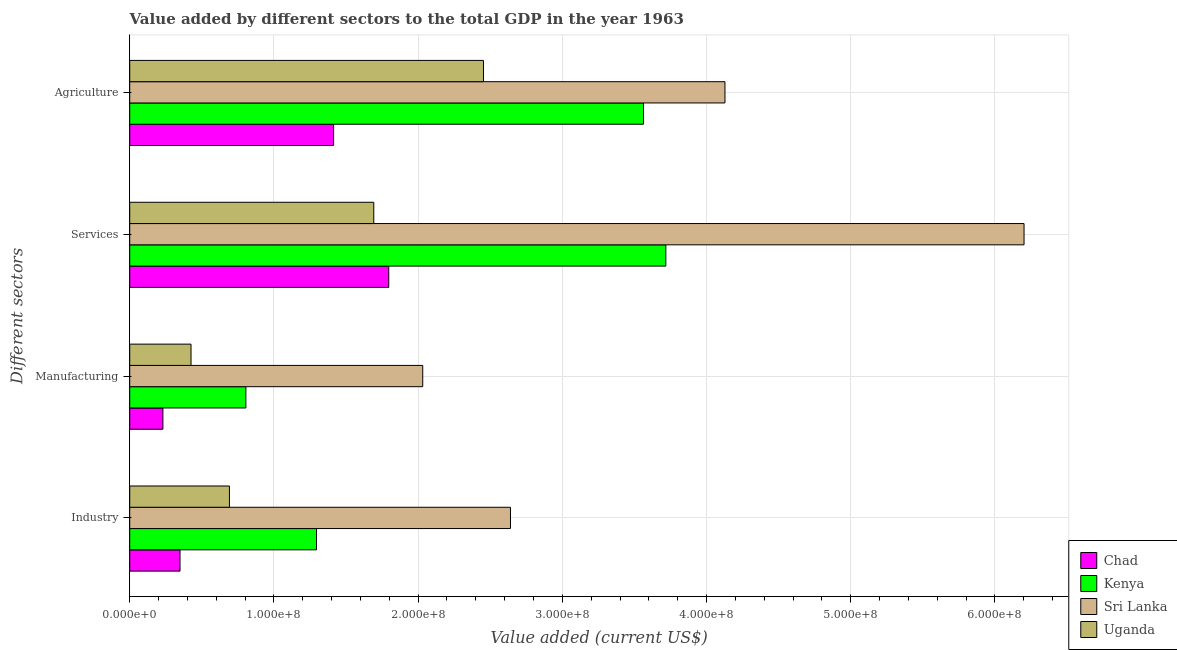How many different coloured bars are there?
Provide a succinct answer. 4. Are the number of bars per tick equal to the number of legend labels?
Ensure brevity in your answer.  Yes. How many bars are there on the 3rd tick from the bottom?
Offer a terse response. 4. What is the label of the 3rd group of bars from the top?
Make the answer very short. Manufacturing. What is the value added by manufacturing sector in Chad?
Your answer should be very brief. 2.30e+07. Across all countries, what is the maximum value added by agricultural sector?
Ensure brevity in your answer.  4.13e+08. Across all countries, what is the minimum value added by agricultural sector?
Ensure brevity in your answer.  1.41e+08. In which country was the value added by services sector maximum?
Offer a very short reply. Sri Lanka. In which country was the value added by services sector minimum?
Offer a terse response. Uganda. What is the total value added by agricultural sector in the graph?
Offer a terse response. 1.16e+09. What is the difference between the value added by industrial sector in Sri Lanka and that in Kenya?
Your answer should be compact. 1.35e+08. What is the difference between the value added by agricultural sector in Uganda and the value added by industrial sector in Sri Lanka?
Provide a short and direct response. -1.87e+07. What is the average value added by manufacturing sector per country?
Your response must be concise. 8.73e+07. What is the difference between the value added by services sector and value added by agricultural sector in Kenya?
Your answer should be compact. 1.55e+07. In how many countries, is the value added by agricultural sector greater than 240000000 US$?
Give a very brief answer. 3. What is the ratio of the value added by industrial sector in Sri Lanka to that in Uganda?
Your answer should be very brief. 3.82. Is the value added by manufacturing sector in Kenya less than that in Sri Lanka?
Provide a succinct answer. Yes. Is the difference between the value added by agricultural sector in Sri Lanka and Kenya greater than the difference between the value added by industrial sector in Sri Lanka and Kenya?
Make the answer very short. No. What is the difference between the highest and the second highest value added by agricultural sector?
Make the answer very short. 5.65e+07. What is the difference between the highest and the lowest value added by agricultural sector?
Your answer should be very brief. 2.71e+08. In how many countries, is the value added by industrial sector greater than the average value added by industrial sector taken over all countries?
Provide a short and direct response. 2. Is the sum of the value added by services sector in Kenya and Sri Lanka greater than the maximum value added by manufacturing sector across all countries?
Give a very brief answer. Yes. What does the 4th bar from the top in Industry represents?
Offer a very short reply. Chad. What does the 1st bar from the bottom in Industry represents?
Provide a short and direct response. Chad. Is it the case that in every country, the sum of the value added by industrial sector and value added by manufacturing sector is greater than the value added by services sector?
Provide a succinct answer. No. How many bars are there?
Your answer should be very brief. 16. Are all the bars in the graph horizontal?
Offer a very short reply. Yes. Are the values on the major ticks of X-axis written in scientific E-notation?
Provide a succinct answer. Yes. Does the graph contain any zero values?
Make the answer very short. No. Does the graph contain grids?
Give a very brief answer. Yes. Where does the legend appear in the graph?
Provide a succinct answer. Bottom right. How many legend labels are there?
Ensure brevity in your answer.  4. What is the title of the graph?
Provide a short and direct response. Value added by different sectors to the total GDP in the year 1963. Does "Timor-Leste" appear as one of the legend labels in the graph?
Offer a very short reply. No. What is the label or title of the X-axis?
Your answer should be very brief. Value added (current US$). What is the label or title of the Y-axis?
Provide a short and direct response. Different sectors. What is the Value added (current US$) in Chad in Industry?
Provide a short and direct response. 3.49e+07. What is the Value added (current US$) in Kenya in Industry?
Make the answer very short. 1.30e+08. What is the Value added (current US$) of Sri Lanka in Industry?
Offer a terse response. 2.64e+08. What is the Value added (current US$) of Uganda in Industry?
Your response must be concise. 6.91e+07. What is the Value added (current US$) in Chad in Manufacturing?
Your response must be concise. 2.30e+07. What is the Value added (current US$) of Kenya in Manufacturing?
Ensure brevity in your answer.  8.05e+07. What is the Value added (current US$) in Sri Lanka in Manufacturing?
Provide a short and direct response. 2.03e+08. What is the Value added (current US$) of Uganda in Manufacturing?
Offer a very short reply. 4.25e+07. What is the Value added (current US$) in Chad in Services?
Provide a short and direct response. 1.80e+08. What is the Value added (current US$) in Kenya in Services?
Keep it short and to the point. 3.72e+08. What is the Value added (current US$) in Sri Lanka in Services?
Provide a succinct answer. 6.20e+08. What is the Value added (current US$) in Uganda in Services?
Provide a short and direct response. 1.69e+08. What is the Value added (current US$) in Chad in Agriculture?
Offer a terse response. 1.41e+08. What is the Value added (current US$) in Kenya in Agriculture?
Ensure brevity in your answer.  3.56e+08. What is the Value added (current US$) of Sri Lanka in Agriculture?
Offer a terse response. 4.13e+08. What is the Value added (current US$) of Uganda in Agriculture?
Offer a terse response. 2.45e+08. Across all Different sectors, what is the maximum Value added (current US$) of Chad?
Your answer should be compact. 1.80e+08. Across all Different sectors, what is the maximum Value added (current US$) in Kenya?
Offer a terse response. 3.72e+08. Across all Different sectors, what is the maximum Value added (current US$) of Sri Lanka?
Offer a very short reply. 6.20e+08. Across all Different sectors, what is the maximum Value added (current US$) in Uganda?
Provide a succinct answer. 2.45e+08. Across all Different sectors, what is the minimum Value added (current US$) of Chad?
Ensure brevity in your answer.  2.30e+07. Across all Different sectors, what is the minimum Value added (current US$) in Kenya?
Provide a succinct answer. 8.05e+07. Across all Different sectors, what is the minimum Value added (current US$) in Sri Lanka?
Your answer should be compact. 2.03e+08. Across all Different sectors, what is the minimum Value added (current US$) in Uganda?
Your response must be concise. 4.25e+07. What is the total Value added (current US$) of Chad in the graph?
Provide a succinct answer. 3.79e+08. What is the total Value added (current US$) in Kenya in the graph?
Provide a succinct answer. 9.38e+08. What is the total Value added (current US$) of Sri Lanka in the graph?
Give a very brief answer. 1.50e+09. What is the total Value added (current US$) in Uganda in the graph?
Your answer should be very brief. 5.26e+08. What is the difference between the Value added (current US$) of Chad in Industry and that in Manufacturing?
Your answer should be very brief. 1.19e+07. What is the difference between the Value added (current US$) of Kenya in Industry and that in Manufacturing?
Give a very brief answer. 4.90e+07. What is the difference between the Value added (current US$) in Sri Lanka in Industry and that in Manufacturing?
Your response must be concise. 6.08e+07. What is the difference between the Value added (current US$) in Uganda in Industry and that in Manufacturing?
Ensure brevity in your answer.  2.66e+07. What is the difference between the Value added (current US$) in Chad in Industry and that in Services?
Make the answer very short. -1.45e+08. What is the difference between the Value added (current US$) in Kenya in Industry and that in Services?
Give a very brief answer. -2.42e+08. What is the difference between the Value added (current US$) of Sri Lanka in Industry and that in Services?
Make the answer very short. -3.56e+08. What is the difference between the Value added (current US$) of Uganda in Industry and that in Services?
Make the answer very short. -1.00e+08. What is the difference between the Value added (current US$) of Chad in Industry and that in Agriculture?
Offer a very short reply. -1.07e+08. What is the difference between the Value added (current US$) of Kenya in Industry and that in Agriculture?
Keep it short and to the point. -2.27e+08. What is the difference between the Value added (current US$) of Sri Lanka in Industry and that in Agriculture?
Your answer should be compact. -1.49e+08. What is the difference between the Value added (current US$) of Uganda in Industry and that in Agriculture?
Ensure brevity in your answer.  -1.76e+08. What is the difference between the Value added (current US$) in Chad in Manufacturing and that in Services?
Provide a short and direct response. -1.57e+08. What is the difference between the Value added (current US$) of Kenya in Manufacturing and that in Services?
Provide a succinct answer. -2.91e+08. What is the difference between the Value added (current US$) of Sri Lanka in Manufacturing and that in Services?
Offer a terse response. -4.17e+08. What is the difference between the Value added (current US$) in Uganda in Manufacturing and that in Services?
Your response must be concise. -1.27e+08. What is the difference between the Value added (current US$) in Chad in Manufacturing and that in Agriculture?
Provide a short and direct response. -1.18e+08. What is the difference between the Value added (current US$) of Kenya in Manufacturing and that in Agriculture?
Make the answer very short. -2.76e+08. What is the difference between the Value added (current US$) in Sri Lanka in Manufacturing and that in Agriculture?
Your response must be concise. -2.10e+08. What is the difference between the Value added (current US$) in Uganda in Manufacturing and that in Agriculture?
Give a very brief answer. -2.03e+08. What is the difference between the Value added (current US$) in Chad in Services and that in Agriculture?
Your answer should be compact. 3.82e+07. What is the difference between the Value added (current US$) in Kenya in Services and that in Agriculture?
Give a very brief answer. 1.55e+07. What is the difference between the Value added (current US$) of Sri Lanka in Services and that in Agriculture?
Make the answer very short. 2.07e+08. What is the difference between the Value added (current US$) in Uganda in Services and that in Agriculture?
Your response must be concise. -7.61e+07. What is the difference between the Value added (current US$) in Chad in Industry and the Value added (current US$) in Kenya in Manufacturing?
Offer a very short reply. -4.57e+07. What is the difference between the Value added (current US$) in Chad in Industry and the Value added (current US$) in Sri Lanka in Manufacturing?
Provide a succinct answer. -1.68e+08. What is the difference between the Value added (current US$) in Chad in Industry and the Value added (current US$) in Uganda in Manufacturing?
Offer a very short reply. -7.63e+06. What is the difference between the Value added (current US$) of Kenya in Industry and the Value added (current US$) of Sri Lanka in Manufacturing?
Provide a short and direct response. -7.37e+07. What is the difference between the Value added (current US$) of Kenya in Industry and the Value added (current US$) of Uganda in Manufacturing?
Offer a terse response. 8.70e+07. What is the difference between the Value added (current US$) in Sri Lanka in Industry and the Value added (current US$) in Uganda in Manufacturing?
Provide a short and direct response. 2.22e+08. What is the difference between the Value added (current US$) of Chad in Industry and the Value added (current US$) of Kenya in Services?
Make the answer very short. -3.37e+08. What is the difference between the Value added (current US$) in Chad in Industry and the Value added (current US$) in Sri Lanka in Services?
Your response must be concise. -5.85e+08. What is the difference between the Value added (current US$) in Chad in Industry and the Value added (current US$) in Uganda in Services?
Keep it short and to the point. -1.34e+08. What is the difference between the Value added (current US$) in Kenya in Industry and the Value added (current US$) in Sri Lanka in Services?
Offer a terse response. -4.91e+08. What is the difference between the Value added (current US$) in Kenya in Industry and the Value added (current US$) in Uganda in Services?
Your answer should be very brief. -3.97e+07. What is the difference between the Value added (current US$) of Sri Lanka in Industry and the Value added (current US$) of Uganda in Services?
Give a very brief answer. 9.48e+07. What is the difference between the Value added (current US$) of Chad in Industry and the Value added (current US$) of Kenya in Agriculture?
Keep it short and to the point. -3.21e+08. What is the difference between the Value added (current US$) in Chad in Industry and the Value added (current US$) in Sri Lanka in Agriculture?
Your answer should be very brief. -3.78e+08. What is the difference between the Value added (current US$) of Chad in Industry and the Value added (current US$) of Uganda in Agriculture?
Keep it short and to the point. -2.10e+08. What is the difference between the Value added (current US$) of Kenya in Industry and the Value added (current US$) of Sri Lanka in Agriculture?
Offer a very short reply. -2.83e+08. What is the difference between the Value added (current US$) in Kenya in Industry and the Value added (current US$) in Uganda in Agriculture?
Keep it short and to the point. -1.16e+08. What is the difference between the Value added (current US$) in Sri Lanka in Industry and the Value added (current US$) in Uganda in Agriculture?
Provide a short and direct response. 1.87e+07. What is the difference between the Value added (current US$) of Chad in Manufacturing and the Value added (current US$) of Kenya in Services?
Your response must be concise. -3.49e+08. What is the difference between the Value added (current US$) of Chad in Manufacturing and the Value added (current US$) of Sri Lanka in Services?
Your response must be concise. -5.97e+08. What is the difference between the Value added (current US$) of Chad in Manufacturing and the Value added (current US$) of Uganda in Services?
Offer a very short reply. -1.46e+08. What is the difference between the Value added (current US$) in Kenya in Manufacturing and the Value added (current US$) in Sri Lanka in Services?
Provide a succinct answer. -5.40e+08. What is the difference between the Value added (current US$) in Kenya in Manufacturing and the Value added (current US$) in Uganda in Services?
Your response must be concise. -8.87e+07. What is the difference between the Value added (current US$) of Sri Lanka in Manufacturing and the Value added (current US$) of Uganda in Services?
Your response must be concise. 3.40e+07. What is the difference between the Value added (current US$) of Chad in Manufacturing and the Value added (current US$) of Kenya in Agriculture?
Your response must be concise. -3.33e+08. What is the difference between the Value added (current US$) of Chad in Manufacturing and the Value added (current US$) of Sri Lanka in Agriculture?
Ensure brevity in your answer.  -3.90e+08. What is the difference between the Value added (current US$) of Chad in Manufacturing and the Value added (current US$) of Uganda in Agriculture?
Your response must be concise. -2.22e+08. What is the difference between the Value added (current US$) in Kenya in Manufacturing and the Value added (current US$) in Sri Lanka in Agriculture?
Your response must be concise. -3.32e+08. What is the difference between the Value added (current US$) of Kenya in Manufacturing and the Value added (current US$) of Uganda in Agriculture?
Offer a terse response. -1.65e+08. What is the difference between the Value added (current US$) in Sri Lanka in Manufacturing and the Value added (current US$) in Uganda in Agriculture?
Your response must be concise. -4.21e+07. What is the difference between the Value added (current US$) in Chad in Services and the Value added (current US$) in Kenya in Agriculture?
Provide a short and direct response. -1.77e+08. What is the difference between the Value added (current US$) in Chad in Services and the Value added (current US$) in Sri Lanka in Agriculture?
Your answer should be very brief. -2.33e+08. What is the difference between the Value added (current US$) of Chad in Services and the Value added (current US$) of Uganda in Agriculture?
Provide a short and direct response. -6.57e+07. What is the difference between the Value added (current US$) of Kenya in Services and the Value added (current US$) of Sri Lanka in Agriculture?
Your answer should be compact. -4.10e+07. What is the difference between the Value added (current US$) in Kenya in Services and the Value added (current US$) in Uganda in Agriculture?
Keep it short and to the point. 1.26e+08. What is the difference between the Value added (current US$) of Sri Lanka in Services and the Value added (current US$) of Uganda in Agriculture?
Offer a very short reply. 3.75e+08. What is the average Value added (current US$) in Chad per Different sectors?
Your response must be concise. 9.47e+07. What is the average Value added (current US$) of Kenya per Different sectors?
Give a very brief answer. 2.35e+08. What is the average Value added (current US$) of Sri Lanka per Different sectors?
Your answer should be compact. 3.75e+08. What is the average Value added (current US$) in Uganda per Different sectors?
Provide a succinct answer. 1.32e+08. What is the difference between the Value added (current US$) in Chad and Value added (current US$) in Kenya in Industry?
Your response must be concise. -9.47e+07. What is the difference between the Value added (current US$) of Chad and Value added (current US$) of Sri Lanka in Industry?
Keep it short and to the point. -2.29e+08. What is the difference between the Value added (current US$) in Chad and Value added (current US$) in Uganda in Industry?
Keep it short and to the point. -3.43e+07. What is the difference between the Value added (current US$) of Kenya and Value added (current US$) of Sri Lanka in Industry?
Provide a succinct answer. -1.35e+08. What is the difference between the Value added (current US$) in Kenya and Value added (current US$) in Uganda in Industry?
Make the answer very short. 6.04e+07. What is the difference between the Value added (current US$) of Sri Lanka and Value added (current US$) of Uganda in Industry?
Your response must be concise. 1.95e+08. What is the difference between the Value added (current US$) of Chad and Value added (current US$) of Kenya in Manufacturing?
Give a very brief answer. -5.75e+07. What is the difference between the Value added (current US$) in Chad and Value added (current US$) in Sri Lanka in Manufacturing?
Offer a very short reply. -1.80e+08. What is the difference between the Value added (current US$) of Chad and Value added (current US$) of Uganda in Manufacturing?
Provide a short and direct response. -1.95e+07. What is the difference between the Value added (current US$) in Kenya and Value added (current US$) in Sri Lanka in Manufacturing?
Provide a succinct answer. -1.23e+08. What is the difference between the Value added (current US$) in Kenya and Value added (current US$) in Uganda in Manufacturing?
Keep it short and to the point. 3.80e+07. What is the difference between the Value added (current US$) of Sri Lanka and Value added (current US$) of Uganda in Manufacturing?
Your answer should be compact. 1.61e+08. What is the difference between the Value added (current US$) of Chad and Value added (current US$) of Kenya in Services?
Your answer should be very brief. -1.92e+08. What is the difference between the Value added (current US$) of Chad and Value added (current US$) of Sri Lanka in Services?
Your response must be concise. -4.41e+08. What is the difference between the Value added (current US$) of Chad and Value added (current US$) of Uganda in Services?
Your answer should be very brief. 1.04e+07. What is the difference between the Value added (current US$) of Kenya and Value added (current US$) of Sri Lanka in Services?
Offer a terse response. -2.48e+08. What is the difference between the Value added (current US$) of Kenya and Value added (current US$) of Uganda in Services?
Provide a succinct answer. 2.03e+08. What is the difference between the Value added (current US$) of Sri Lanka and Value added (current US$) of Uganda in Services?
Ensure brevity in your answer.  4.51e+08. What is the difference between the Value added (current US$) in Chad and Value added (current US$) in Kenya in Agriculture?
Your response must be concise. -2.15e+08. What is the difference between the Value added (current US$) of Chad and Value added (current US$) of Sri Lanka in Agriculture?
Offer a very short reply. -2.71e+08. What is the difference between the Value added (current US$) of Chad and Value added (current US$) of Uganda in Agriculture?
Ensure brevity in your answer.  -1.04e+08. What is the difference between the Value added (current US$) of Kenya and Value added (current US$) of Sri Lanka in Agriculture?
Make the answer very short. -5.65e+07. What is the difference between the Value added (current US$) in Kenya and Value added (current US$) in Uganda in Agriculture?
Your answer should be very brief. 1.11e+08. What is the difference between the Value added (current US$) in Sri Lanka and Value added (current US$) in Uganda in Agriculture?
Your answer should be very brief. 1.67e+08. What is the ratio of the Value added (current US$) in Chad in Industry to that in Manufacturing?
Give a very brief answer. 1.52. What is the ratio of the Value added (current US$) of Kenya in Industry to that in Manufacturing?
Offer a terse response. 1.61. What is the ratio of the Value added (current US$) in Sri Lanka in Industry to that in Manufacturing?
Offer a terse response. 1.3. What is the ratio of the Value added (current US$) in Uganda in Industry to that in Manufacturing?
Your answer should be very brief. 1.63. What is the ratio of the Value added (current US$) of Chad in Industry to that in Services?
Offer a terse response. 0.19. What is the ratio of the Value added (current US$) of Kenya in Industry to that in Services?
Offer a very short reply. 0.35. What is the ratio of the Value added (current US$) of Sri Lanka in Industry to that in Services?
Offer a very short reply. 0.43. What is the ratio of the Value added (current US$) in Uganda in Industry to that in Services?
Provide a short and direct response. 0.41. What is the ratio of the Value added (current US$) of Chad in Industry to that in Agriculture?
Provide a succinct answer. 0.25. What is the ratio of the Value added (current US$) of Kenya in Industry to that in Agriculture?
Keep it short and to the point. 0.36. What is the ratio of the Value added (current US$) of Sri Lanka in Industry to that in Agriculture?
Provide a short and direct response. 0.64. What is the ratio of the Value added (current US$) of Uganda in Industry to that in Agriculture?
Give a very brief answer. 0.28. What is the ratio of the Value added (current US$) of Chad in Manufacturing to that in Services?
Your answer should be very brief. 0.13. What is the ratio of the Value added (current US$) of Kenya in Manufacturing to that in Services?
Provide a short and direct response. 0.22. What is the ratio of the Value added (current US$) in Sri Lanka in Manufacturing to that in Services?
Ensure brevity in your answer.  0.33. What is the ratio of the Value added (current US$) in Uganda in Manufacturing to that in Services?
Your answer should be compact. 0.25. What is the ratio of the Value added (current US$) in Chad in Manufacturing to that in Agriculture?
Provide a short and direct response. 0.16. What is the ratio of the Value added (current US$) in Kenya in Manufacturing to that in Agriculture?
Ensure brevity in your answer.  0.23. What is the ratio of the Value added (current US$) in Sri Lanka in Manufacturing to that in Agriculture?
Keep it short and to the point. 0.49. What is the ratio of the Value added (current US$) in Uganda in Manufacturing to that in Agriculture?
Give a very brief answer. 0.17. What is the ratio of the Value added (current US$) in Chad in Services to that in Agriculture?
Keep it short and to the point. 1.27. What is the ratio of the Value added (current US$) of Kenya in Services to that in Agriculture?
Make the answer very short. 1.04. What is the ratio of the Value added (current US$) in Sri Lanka in Services to that in Agriculture?
Your answer should be compact. 1.5. What is the ratio of the Value added (current US$) of Uganda in Services to that in Agriculture?
Your response must be concise. 0.69. What is the difference between the highest and the second highest Value added (current US$) in Chad?
Offer a terse response. 3.82e+07. What is the difference between the highest and the second highest Value added (current US$) of Kenya?
Your answer should be very brief. 1.55e+07. What is the difference between the highest and the second highest Value added (current US$) of Sri Lanka?
Give a very brief answer. 2.07e+08. What is the difference between the highest and the second highest Value added (current US$) in Uganda?
Keep it short and to the point. 7.61e+07. What is the difference between the highest and the lowest Value added (current US$) in Chad?
Your answer should be very brief. 1.57e+08. What is the difference between the highest and the lowest Value added (current US$) of Kenya?
Provide a succinct answer. 2.91e+08. What is the difference between the highest and the lowest Value added (current US$) of Sri Lanka?
Ensure brevity in your answer.  4.17e+08. What is the difference between the highest and the lowest Value added (current US$) in Uganda?
Your answer should be compact. 2.03e+08. 